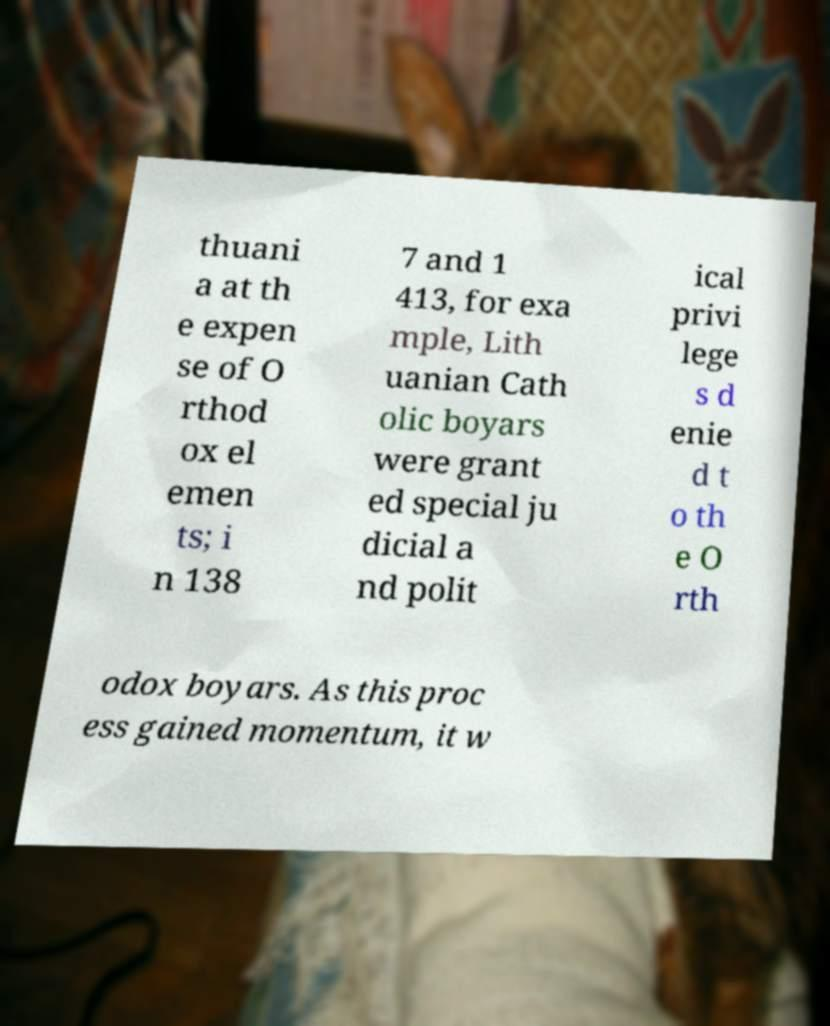There's text embedded in this image that I need extracted. Can you transcribe it verbatim? thuani a at th e expen se of O rthod ox el emen ts; i n 138 7 and 1 413, for exa mple, Lith uanian Cath olic boyars were grant ed special ju dicial a nd polit ical privi lege s d enie d t o th e O rth odox boyars. As this proc ess gained momentum, it w 